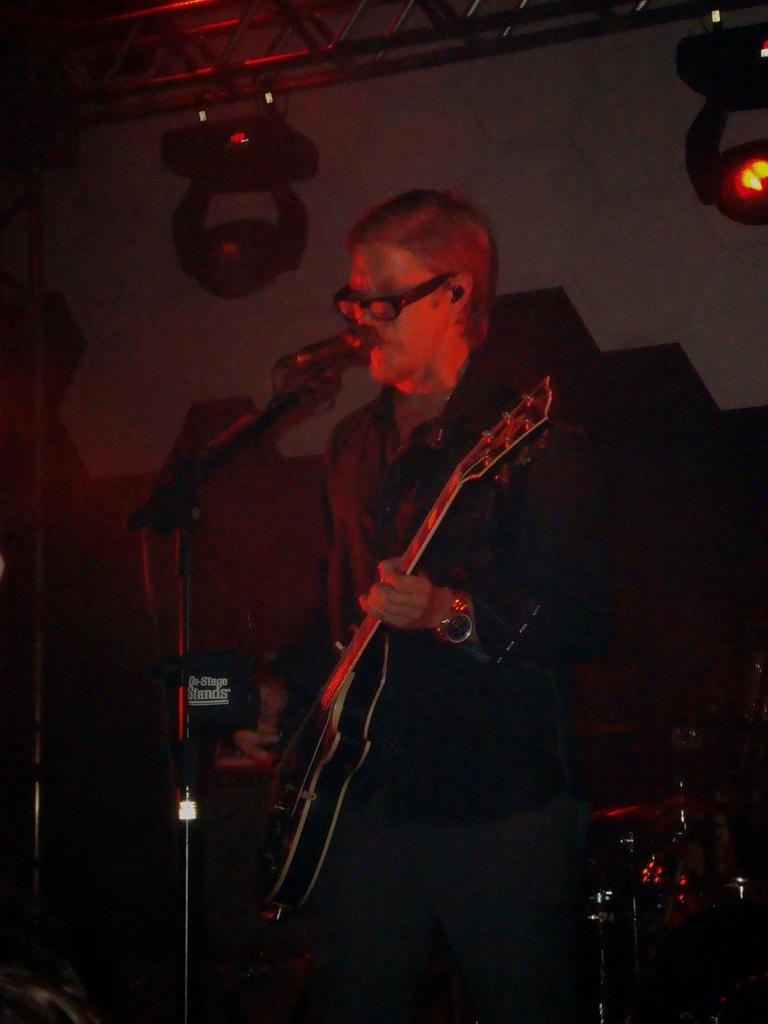What is the man in the image doing? The man is singing in front of a microphone and holding a guitar. What object is the man holding in the image? The man is holding a guitar. What can be seen in the background of the image? There is a wall, lights, and musical instruments in the background of the image. What type of lettuce is being used as an ornament in the image? There is no lettuce present in the image, and no ornaments are mentioned in the provided facts. 